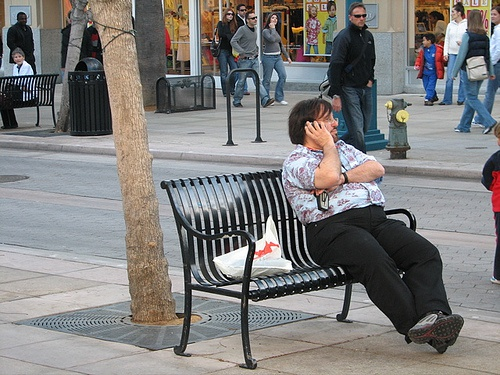Describe the objects in this image and their specific colors. I can see people in maroon, black, darkgray, lightgray, and tan tones, bench in maroon, black, darkgray, lightgray, and gray tones, people in maroon, black, blue, gray, and darkblue tones, people in maroon, black, gray, and blue tones, and handbag in maroon, white, darkgray, gray, and black tones in this image. 